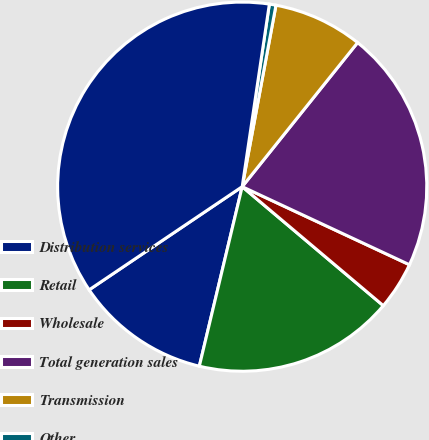Convert chart. <chart><loc_0><loc_0><loc_500><loc_500><pie_chart><fcel>Distribution services<fcel>Retail<fcel>Wholesale<fcel>Total generation sales<fcel>Transmission<fcel>Other<fcel>Total Revenues<nl><fcel>11.83%<fcel>17.58%<fcel>4.2%<fcel>21.2%<fcel>7.82%<fcel>0.58%<fcel>36.79%<nl></chart> 